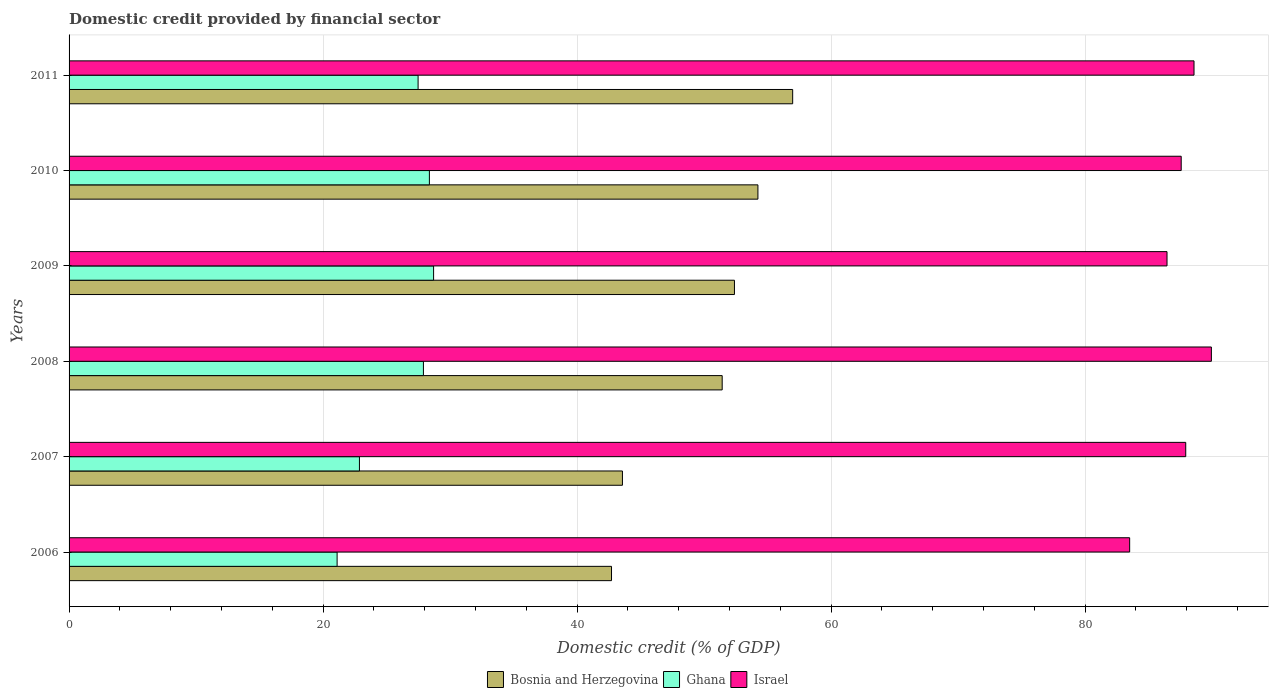How many different coloured bars are there?
Offer a very short reply. 3. How many groups of bars are there?
Keep it short and to the point. 6. Are the number of bars per tick equal to the number of legend labels?
Your answer should be very brief. Yes. Are the number of bars on each tick of the Y-axis equal?
Provide a succinct answer. Yes. How many bars are there on the 6th tick from the top?
Offer a very short reply. 3. How many bars are there on the 5th tick from the bottom?
Your answer should be very brief. 3. What is the label of the 2nd group of bars from the top?
Your answer should be very brief. 2010. What is the domestic credit in Ghana in 2007?
Keep it short and to the point. 22.86. Across all years, what is the maximum domestic credit in Israel?
Your answer should be very brief. 89.94. Across all years, what is the minimum domestic credit in Ghana?
Your answer should be compact. 21.1. In which year was the domestic credit in Bosnia and Herzegovina maximum?
Keep it short and to the point. 2011. In which year was the domestic credit in Israel minimum?
Your answer should be compact. 2006. What is the total domestic credit in Israel in the graph?
Your answer should be compact. 523.95. What is the difference between the domestic credit in Ghana in 2007 and that in 2009?
Ensure brevity in your answer.  -5.84. What is the difference between the domestic credit in Bosnia and Herzegovina in 2008 and the domestic credit in Ghana in 2007?
Your answer should be compact. 28.56. What is the average domestic credit in Israel per year?
Offer a very short reply. 87.32. In the year 2010, what is the difference between the domestic credit in Bosnia and Herzegovina and domestic credit in Ghana?
Provide a succinct answer. 25.87. What is the ratio of the domestic credit in Bosnia and Herzegovina in 2006 to that in 2007?
Your answer should be compact. 0.98. Is the domestic credit in Ghana in 2008 less than that in 2009?
Provide a short and direct response. Yes. What is the difference between the highest and the second highest domestic credit in Ghana?
Offer a very short reply. 0.33. What is the difference between the highest and the lowest domestic credit in Bosnia and Herzegovina?
Ensure brevity in your answer.  14.26. In how many years, is the domestic credit in Israel greater than the average domestic credit in Israel taken over all years?
Your answer should be very brief. 4. What does the 3rd bar from the top in 2010 represents?
Ensure brevity in your answer.  Bosnia and Herzegovina. What does the 1st bar from the bottom in 2010 represents?
Your answer should be very brief. Bosnia and Herzegovina. Are all the bars in the graph horizontal?
Make the answer very short. Yes. Where does the legend appear in the graph?
Your answer should be compact. Bottom center. How many legend labels are there?
Keep it short and to the point. 3. What is the title of the graph?
Offer a terse response. Domestic credit provided by financial sector. What is the label or title of the X-axis?
Provide a short and direct response. Domestic credit (% of GDP). What is the label or title of the Y-axis?
Give a very brief answer. Years. What is the Domestic credit (% of GDP) in Bosnia and Herzegovina in 2006?
Offer a terse response. 42.71. What is the Domestic credit (% of GDP) in Ghana in 2006?
Provide a succinct answer. 21.1. What is the Domestic credit (% of GDP) in Israel in 2006?
Your answer should be very brief. 83.51. What is the Domestic credit (% of GDP) in Bosnia and Herzegovina in 2007?
Provide a short and direct response. 43.57. What is the Domestic credit (% of GDP) of Ghana in 2007?
Provide a succinct answer. 22.86. What is the Domestic credit (% of GDP) of Israel in 2007?
Keep it short and to the point. 87.92. What is the Domestic credit (% of GDP) in Bosnia and Herzegovina in 2008?
Offer a very short reply. 51.42. What is the Domestic credit (% of GDP) in Ghana in 2008?
Make the answer very short. 27.9. What is the Domestic credit (% of GDP) of Israel in 2008?
Provide a succinct answer. 89.94. What is the Domestic credit (% of GDP) of Bosnia and Herzegovina in 2009?
Give a very brief answer. 52.39. What is the Domestic credit (% of GDP) in Ghana in 2009?
Offer a terse response. 28.7. What is the Domestic credit (% of GDP) in Israel in 2009?
Make the answer very short. 86.45. What is the Domestic credit (% of GDP) in Bosnia and Herzegovina in 2010?
Provide a short and direct response. 54.24. What is the Domestic credit (% of GDP) of Ghana in 2010?
Provide a short and direct response. 28.37. What is the Domestic credit (% of GDP) in Israel in 2010?
Offer a terse response. 87.56. What is the Domestic credit (% of GDP) in Bosnia and Herzegovina in 2011?
Offer a very short reply. 56.97. What is the Domestic credit (% of GDP) in Ghana in 2011?
Provide a succinct answer. 27.48. What is the Domestic credit (% of GDP) in Israel in 2011?
Offer a terse response. 88.57. Across all years, what is the maximum Domestic credit (% of GDP) in Bosnia and Herzegovina?
Provide a short and direct response. 56.97. Across all years, what is the maximum Domestic credit (% of GDP) in Ghana?
Offer a terse response. 28.7. Across all years, what is the maximum Domestic credit (% of GDP) in Israel?
Offer a terse response. 89.94. Across all years, what is the minimum Domestic credit (% of GDP) of Bosnia and Herzegovina?
Your response must be concise. 42.71. Across all years, what is the minimum Domestic credit (% of GDP) in Ghana?
Offer a very short reply. 21.1. Across all years, what is the minimum Domestic credit (% of GDP) in Israel?
Provide a short and direct response. 83.51. What is the total Domestic credit (% of GDP) in Bosnia and Herzegovina in the graph?
Offer a very short reply. 301.3. What is the total Domestic credit (% of GDP) of Ghana in the graph?
Offer a very short reply. 156.42. What is the total Domestic credit (% of GDP) in Israel in the graph?
Keep it short and to the point. 523.95. What is the difference between the Domestic credit (% of GDP) in Bosnia and Herzegovina in 2006 and that in 2007?
Provide a short and direct response. -0.86. What is the difference between the Domestic credit (% of GDP) of Ghana in 2006 and that in 2007?
Make the answer very short. -1.76. What is the difference between the Domestic credit (% of GDP) in Israel in 2006 and that in 2007?
Keep it short and to the point. -4.42. What is the difference between the Domestic credit (% of GDP) in Bosnia and Herzegovina in 2006 and that in 2008?
Give a very brief answer. -8.71. What is the difference between the Domestic credit (% of GDP) in Ghana in 2006 and that in 2008?
Offer a very short reply. -6.8. What is the difference between the Domestic credit (% of GDP) of Israel in 2006 and that in 2008?
Give a very brief answer. -6.43. What is the difference between the Domestic credit (% of GDP) of Bosnia and Herzegovina in 2006 and that in 2009?
Keep it short and to the point. -9.68. What is the difference between the Domestic credit (% of GDP) in Ghana in 2006 and that in 2009?
Your answer should be very brief. -7.6. What is the difference between the Domestic credit (% of GDP) of Israel in 2006 and that in 2009?
Give a very brief answer. -2.94. What is the difference between the Domestic credit (% of GDP) in Bosnia and Herzegovina in 2006 and that in 2010?
Make the answer very short. -11.53. What is the difference between the Domestic credit (% of GDP) of Ghana in 2006 and that in 2010?
Provide a short and direct response. -7.27. What is the difference between the Domestic credit (% of GDP) of Israel in 2006 and that in 2010?
Your response must be concise. -4.06. What is the difference between the Domestic credit (% of GDP) in Bosnia and Herzegovina in 2006 and that in 2011?
Provide a succinct answer. -14.26. What is the difference between the Domestic credit (% of GDP) of Ghana in 2006 and that in 2011?
Your answer should be very brief. -6.38. What is the difference between the Domestic credit (% of GDP) in Israel in 2006 and that in 2011?
Ensure brevity in your answer.  -5.07. What is the difference between the Domestic credit (% of GDP) in Bosnia and Herzegovina in 2007 and that in 2008?
Provide a short and direct response. -7.85. What is the difference between the Domestic credit (% of GDP) in Ghana in 2007 and that in 2008?
Offer a terse response. -5.04. What is the difference between the Domestic credit (% of GDP) in Israel in 2007 and that in 2008?
Provide a succinct answer. -2.02. What is the difference between the Domestic credit (% of GDP) in Bosnia and Herzegovina in 2007 and that in 2009?
Your answer should be very brief. -8.82. What is the difference between the Domestic credit (% of GDP) of Ghana in 2007 and that in 2009?
Your answer should be compact. -5.84. What is the difference between the Domestic credit (% of GDP) in Israel in 2007 and that in 2009?
Give a very brief answer. 1.47. What is the difference between the Domestic credit (% of GDP) of Bosnia and Herzegovina in 2007 and that in 2010?
Provide a succinct answer. -10.67. What is the difference between the Domestic credit (% of GDP) of Ghana in 2007 and that in 2010?
Provide a succinct answer. -5.51. What is the difference between the Domestic credit (% of GDP) in Israel in 2007 and that in 2010?
Keep it short and to the point. 0.36. What is the difference between the Domestic credit (% of GDP) in Bosnia and Herzegovina in 2007 and that in 2011?
Offer a terse response. -13.4. What is the difference between the Domestic credit (% of GDP) in Ghana in 2007 and that in 2011?
Keep it short and to the point. -4.62. What is the difference between the Domestic credit (% of GDP) in Israel in 2007 and that in 2011?
Provide a short and direct response. -0.65. What is the difference between the Domestic credit (% of GDP) of Bosnia and Herzegovina in 2008 and that in 2009?
Keep it short and to the point. -0.97. What is the difference between the Domestic credit (% of GDP) in Ghana in 2008 and that in 2009?
Provide a short and direct response. -0.8. What is the difference between the Domestic credit (% of GDP) of Israel in 2008 and that in 2009?
Ensure brevity in your answer.  3.49. What is the difference between the Domestic credit (% of GDP) in Bosnia and Herzegovina in 2008 and that in 2010?
Make the answer very short. -2.81. What is the difference between the Domestic credit (% of GDP) of Ghana in 2008 and that in 2010?
Offer a very short reply. -0.47. What is the difference between the Domestic credit (% of GDP) in Israel in 2008 and that in 2010?
Your answer should be very brief. 2.38. What is the difference between the Domestic credit (% of GDP) of Bosnia and Herzegovina in 2008 and that in 2011?
Provide a short and direct response. -5.55. What is the difference between the Domestic credit (% of GDP) of Ghana in 2008 and that in 2011?
Give a very brief answer. 0.42. What is the difference between the Domestic credit (% of GDP) in Israel in 2008 and that in 2011?
Give a very brief answer. 1.37. What is the difference between the Domestic credit (% of GDP) of Bosnia and Herzegovina in 2009 and that in 2010?
Give a very brief answer. -1.85. What is the difference between the Domestic credit (% of GDP) of Ghana in 2009 and that in 2010?
Ensure brevity in your answer.  0.33. What is the difference between the Domestic credit (% of GDP) of Israel in 2009 and that in 2010?
Your answer should be compact. -1.12. What is the difference between the Domestic credit (% of GDP) of Bosnia and Herzegovina in 2009 and that in 2011?
Keep it short and to the point. -4.58. What is the difference between the Domestic credit (% of GDP) of Ghana in 2009 and that in 2011?
Keep it short and to the point. 1.22. What is the difference between the Domestic credit (% of GDP) of Israel in 2009 and that in 2011?
Make the answer very short. -2.12. What is the difference between the Domestic credit (% of GDP) of Bosnia and Herzegovina in 2010 and that in 2011?
Keep it short and to the point. -2.74. What is the difference between the Domestic credit (% of GDP) in Ghana in 2010 and that in 2011?
Provide a short and direct response. 0.89. What is the difference between the Domestic credit (% of GDP) of Israel in 2010 and that in 2011?
Your response must be concise. -1.01. What is the difference between the Domestic credit (% of GDP) of Bosnia and Herzegovina in 2006 and the Domestic credit (% of GDP) of Ghana in 2007?
Your response must be concise. 19.85. What is the difference between the Domestic credit (% of GDP) of Bosnia and Herzegovina in 2006 and the Domestic credit (% of GDP) of Israel in 2007?
Provide a short and direct response. -45.21. What is the difference between the Domestic credit (% of GDP) in Ghana in 2006 and the Domestic credit (% of GDP) in Israel in 2007?
Your response must be concise. -66.82. What is the difference between the Domestic credit (% of GDP) in Bosnia and Herzegovina in 2006 and the Domestic credit (% of GDP) in Ghana in 2008?
Ensure brevity in your answer.  14.81. What is the difference between the Domestic credit (% of GDP) of Bosnia and Herzegovina in 2006 and the Domestic credit (% of GDP) of Israel in 2008?
Your answer should be compact. -47.23. What is the difference between the Domestic credit (% of GDP) of Ghana in 2006 and the Domestic credit (% of GDP) of Israel in 2008?
Make the answer very short. -68.84. What is the difference between the Domestic credit (% of GDP) in Bosnia and Herzegovina in 2006 and the Domestic credit (% of GDP) in Ghana in 2009?
Give a very brief answer. 14.01. What is the difference between the Domestic credit (% of GDP) of Bosnia and Herzegovina in 2006 and the Domestic credit (% of GDP) of Israel in 2009?
Your response must be concise. -43.74. What is the difference between the Domestic credit (% of GDP) in Ghana in 2006 and the Domestic credit (% of GDP) in Israel in 2009?
Provide a succinct answer. -65.34. What is the difference between the Domestic credit (% of GDP) of Bosnia and Herzegovina in 2006 and the Domestic credit (% of GDP) of Ghana in 2010?
Make the answer very short. 14.34. What is the difference between the Domestic credit (% of GDP) of Bosnia and Herzegovina in 2006 and the Domestic credit (% of GDP) of Israel in 2010?
Give a very brief answer. -44.85. What is the difference between the Domestic credit (% of GDP) in Ghana in 2006 and the Domestic credit (% of GDP) in Israel in 2010?
Your answer should be very brief. -66.46. What is the difference between the Domestic credit (% of GDP) in Bosnia and Herzegovina in 2006 and the Domestic credit (% of GDP) in Ghana in 2011?
Ensure brevity in your answer.  15.23. What is the difference between the Domestic credit (% of GDP) of Bosnia and Herzegovina in 2006 and the Domestic credit (% of GDP) of Israel in 2011?
Your response must be concise. -45.86. What is the difference between the Domestic credit (% of GDP) in Ghana in 2006 and the Domestic credit (% of GDP) in Israel in 2011?
Keep it short and to the point. -67.47. What is the difference between the Domestic credit (% of GDP) of Bosnia and Herzegovina in 2007 and the Domestic credit (% of GDP) of Ghana in 2008?
Your answer should be compact. 15.67. What is the difference between the Domestic credit (% of GDP) in Bosnia and Herzegovina in 2007 and the Domestic credit (% of GDP) in Israel in 2008?
Provide a short and direct response. -46.37. What is the difference between the Domestic credit (% of GDP) of Ghana in 2007 and the Domestic credit (% of GDP) of Israel in 2008?
Ensure brevity in your answer.  -67.08. What is the difference between the Domestic credit (% of GDP) in Bosnia and Herzegovina in 2007 and the Domestic credit (% of GDP) in Ghana in 2009?
Ensure brevity in your answer.  14.87. What is the difference between the Domestic credit (% of GDP) in Bosnia and Herzegovina in 2007 and the Domestic credit (% of GDP) in Israel in 2009?
Provide a succinct answer. -42.88. What is the difference between the Domestic credit (% of GDP) in Ghana in 2007 and the Domestic credit (% of GDP) in Israel in 2009?
Provide a succinct answer. -63.58. What is the difference between the Domestic credit (% of GDP) of Bosnia and Herzegovina in 2007 and the Domestic credit (% of GDP) of Ghana in 2010?
Offer a terse response. 15.2. What is the difference between the Domestic credit (% of GDP) of Bosnia and Herzegovina in 2007 and the Domestic credit (% of GDP) of Israel in 2010?
Your answer should be compact. -43.99. What is the difference between the Domestic credit (% of GDP) of Ghana in 2007 and the Domestic credit (% of GDP) of Israel in 2010?
Your answer should be compact. -64.7. What is the difference between the Domestic credit (% of GDP) of Bosnia and Herzegovina in 2007 and the Domestic credit (% of GDP) of Ghana in 2011?
Keep it short and to the point. 16.09. What is the difference between the Domestic credit (% of GDP) of Bosnia and Herzegovina in 2007 and the Domestic credit (% of GDP) of Israel in 2011?
Offer a terse response. -45. What is the difference between the Domestic credit (% of GDP) of Ghana in 2007 and the Domestic credit (% of GDP) of Israel in 2011?
Give a very brief answer. -65.71. What is the difference between the Domestic credit (% of GDP) in Bosnia and Herzegovina in 2008 and the Domestic credit (% of GDP) in Ghana in 2009?
Offer a very short reply. 22.72. What is the difference between the Domestic credit (% of GDP) in Bosnia and Herzegovina in 2008 and the Domestic credit (% of GDP) in Israel in 2009?
Ensure brevity in your answer.  -35.02. What is the difference between the Domestic credit (% of GDP) of Ghana in 2008 and the Domestic credit (% of GDP) of Israel in 2009?
Your answer should be compact. -58.55. What is the difference between the Domestic credit (% of GDP) of Bosnia and Herzegovina in 2008 and the Domestic credit (% of GDP) of Ghana in 2010?
Your answer should be compact. 23.05. What is the difference between the Domestic credit (% of GDP) of Bosnia and Herzegovina in 2008 and the Domestic credit (% of GDP) of Israel in 2010?
Provide a succinct answer. -36.14. What is the difference between the Domestic credit (% of GDP) of Ghana in 2008 and the Domestic credit (% of GDP) of Israel in 2010?
Your response must be concise. -59.66. What is the difference between the Domestic credit (% of GDP) of Bosnia and Herzegovina in 2008 and the Domestic credit (% of GDP) of Ghana in 2011?
Offer a very short reply. 23.94. What is the difference between the Domestic credit (% of GDP) in Bosnia and Herzegovina in 2008 and the Domestic credit (% of GDP) in Israel in 2011?
Keep it short and to the point. -37.15. What is the difference between the Domestic credit (% of GDP) of Ghana in 2008 and the Domestic credit (% of GDP) of Israel in 2011?
Offer a terse response. -60.67. What is the difference between the Domestic credit (% of GDP) of Bosnia and Herzegovina in 2009 and the Domestic credit (% of GDP) of Ghana in 2010?
Your answer should be very brief. 24.02. What is the difference between the Domestic credit (% of GDP) in Bosnia and Herzegovina in 2009 and the Domestic credit (% of GDP) in Israel in 2010?
Your answer should be compact. -35.17. What is the difference between the Domestic credit (% of GDP) in Ghana in 2009 and the Domestic credit (% of GDP) in Israel in 2010?
Offer a very short reply. -58.86. What is the difference between the Domestic credit (% of GDP) in Bosnia and Herzegovina in 2009 and the Domestic credit (% of GDP) in Ghana in 2011?
Your answer should be very brief. 24.91. What is the difference between the Domestic credit (% of GDP) in Bosnia and Herzegovina in 2009 and the Domestic credit (% of GDP) in Israel in 2011?
Give a very brief answer. -36.18. What is the difference between the Domestic credit (% of GDP) of Ghana in 2009 and the Domestic credit (% of GDP) of Israel in 2011?
Offer a very short reply. -59.87. What is the difference between the Domestic credit (% of GDP) of Bosnia and Herzegovina in 2010 and the Domestic credit (% of GDP) of Ghana in 2011?
Ensure brevity in your answer.  26.76. What is the difference between the Domestic credit (% of GDP) of Bosnia and Herzegovina in 2010 and the Domestic credit (% of GDP) of Israel in 2011?
Make the answer very short. -34.33. What is the difference between the Domestic credit (% of GDP) in Ghana in 2010 and the Domestic credit (% of GDP) in Israel in 2011?
Provide a succinct answer. -60.2. What is the average Domestic credit (% of GDP) of Bosnia and Herzegovina per year?
Provide a short and direct response. 50.22. What is the average Domestic credit (% of GDP) in Ghana per year?
Offer a very short reply. 26.07. What is the average Domestic credit (% of GDP) in Israel per year?
Provide a short and direct response. 87.32. In the year 2006, what is the difference between the Domestic credit (% of GDP) in Bosnia and Herzegovina and Domestic credit (% of GDP) in Ghana?
Keep it short and to the point. 21.6. In the year 2006, what is the difference between the Domestic credit (% of GDP) in Bosnia and Herzegovina and Domestic credit (% of GDP) in Israel?
Keep it short and to the point. -40.8. In the year 2006, what is the difference between the Domestic credit (% of GDP) of Ghana and Domestic credit (% of GDP) of Israel?
Offer a terse response. -62.4. In the year 2007, what is the difference between the Domestic credit (% of GDP) of Bosnia and Herzegovina and Domestic credit (% of GDP) of Ghana?
Your response must be concise. 20.71. In the year 2007, what is the difference between the Domestic credit (% of GDP) in Bosnia and Herzegovina and Domestic credit (% of GDP) in Israel?
Give a very brief answer. -44.35. In the year 2007, what is the difference between the Domestic credit (% of GDP) of Ghana and Domestic credit (% of GDP) of Israel?
Provide a short and direct response. -65.06. In the year 2008, what is the difference between the Domestic credit (% of GDP) of Bosnia and Herzegovina and Domestic credit (% of GDP) of Ghana?
Offer a terse response. 23.52. In the year 2008, what is the difference between the Domestic credit (% of GDP) of Bosnia and Herzegovina and Domestic credit (% of GDP) of Israel?
Your response must be concise. -38.52. In the year 2008, what is the difference between the Domestic credit (% of GDP) in Ghana and Domestic credit (% of GDP) in Israel?
Keep it short and to the point. -62.04. In the year 2009, what is the difference between the Domestic credit (% of GDP) in Bosnia and Herzegovina and Domestic credit (% of GDP) in Ghana?
Offer a very short reply. 23.69. In the year 2009, what is the difference between the Domestic credit (% of GDP) of Bosnia and Herzegovina and Domestic credit (% of GDP) of Israel?
Your response must be concise. -34.06. In the year 2009, what is the difference between the Domestic credit (% of GDP) of Ghana and Domestic credit (% of GDP) of Israel?
Offer a terse response. -57.75. In the year 2010, what is the difference between the Domestic credit (% of GDP) in Bosnia and Herzegovina and Domestic credit (% of GDP) in Ghana?
Make the answer very short. 25.87. In the year 2010, what is the difference between the Domestic credit (% of GDP) of Bosnia and Herzegovina and Domestic credit (% of GDP) of Israel?
Keep it short and to the point. -33.33. In the year 2010, what is the difference between the Domestic credit (% of GDP) in Ghana and Domestic credit (% of GDP) in Israel?
Ensure brevity in your answer.  -59.19. In the year 2011, what is the difference between the Domestic credit (% of GDP) of Bosnia and Herzegovina and Domestic credit (% of GDP) of Ghana?
Your answer should be compact. 29.49. In the year 2011, what is the difference between the Domestic credit (% of GDP) of Bosnia and Herzegovina and Domestic credit (% of GDP) of Israel?
Give a very brief answer. -31.6. In the year 2011, what is the difference between the Domestic credit (% of GDP) in Ghana and Domestic credit (% of GDP) in Israel?
Provide a succinct answer. -61.09. What is the ratio of the Domestic credit (% of GDP) of Bosnia and Herzegovina in 2006 to that in 2007?
Offer a very short reply. 0.98. What is the ratio of the Domestic credit (% of GDP) in Ghana in 2006 to that in 2007?
Your answer should be compact. 0.92. What is the ratio of the Domestic credit (% of GDP) of Israel in 2006 to that in 2007?
Keep it short and to the point. 0.95. What is the ratio of the Domestic credit (% of GDP) in Bosnia and Herzegovina in 2006 to that in 2008?
Give a very brief answer. 0.83. What is the ratio of the Domestic credit (% of GDP) of Ghana in 2006 to that in 2008?
Your answer should be very brief. 0.76. What is the ratio of the Domestic credit (% of GDP) in Israel in 2006 to that in 2008?
Your answer should be very brief. 0.93. What is the ratio of the Domestic credit (% of GDP) in Bosnia and Herzegovina in 2006 to that in 2009?
Offer a terse response. 0.82. What is the ratio of the Domestic credit (% of GDP) in Ghana in 2006 to that in 2009?
Your answer should be compact. 0.74. What is the ratio of the Domestic credit (% of GDP) of Israel in 2006 to that in 2009?
Give a very brief answer. 0.97. What is the ratio of the Domestic credit (% of GDP) of Bosnia and Herzegovina in 2006 to that in 2010?
Offer a terse response. 0.79. What is the ratio of the Domestic credit (% of GDP) of Ghana in 2006 to that in 2010?
Ensure brevity in your answer.  0.74. What is the ratio of the Domestic credit (% of GDP) in Israel in 2006 to that in 2010?
Offer a very short reply. 0.95. What is the ratio of the Domestic credit (% of GDP) in Bosnia and Herzegovina in 2006 to that in 2011?
Provide a succinct answer. 0.75. What is the ratio of the Domestic credit (% of GDP) in Ghana in 2006 to that in 2011?
Your answer should be very brief. 0.77. What is the ratio of the Domestic credit (% of GDP) in Israel in 2006 to that in 2011?
Give a very brief answer. 0.94. What is the ratio of the Domestic credit (% of GDP) of Bosnia and Herzegovina in 2007 to that in 2008?
Your response must be concise. 0.85. What is the ratio of the Domestic credit (% of GDP) in Ghana in 2007 to that in 2008?
Offer a very short reply. 0.82. What is the ratio of the Domestic credit (% of GDP) in Israel in 2007 to that in 2008?
Keep it short and to the point. 0.98. What is the ratio of the Domestic credit (% of GDP) in Bosnia and Herzegovina in 2007 to that in 2009?
Your response must be concise. 0.83. What is the ratio of the Domestic credit (% of GDP) of Ghana in 2007 to that in 2009?
Offer a very short reply. 0.8. What is the ratio of the Domestic credit (% of GDP) of Bosnia and Herzegovina in 2007 to that in 2010?
Your answer should be very brief. 0.8. What is the ratio of the Domestic credit (% of GDP) of Ghana in 2007 to that in 2010?
Your answer should be compact. 0.81. What is the ratio of the Domestic credit (% of GDP) of Israel in 2007 to that in 2010?
Provide a short and direct response. 1. What is the ratio of the Domestic credit (% of GDP) of Bosnia and Herzegovina in 2007 to that in 2011?
Provide a short and direct response. 0.76. What is the ratio of the Domestic credit (% of GDP) in Ghana in 2007 to that in 2011?
Keep it short and to the point. 0.83. What is the ratio of the Domestic credit (% of GDP) of Israel in 2007 to that in 2011?
Your answer should be compact. 0.99. What is the ratio of the Domestic credit (% of GDP) of Bosnia and Herzegovina in 2008 to that in 2009?
Offer a terse response. 0.98. What is the ratio of the Domestic credit (% of GDP) of Ghana in 2008 to that in 2009?
Ensure brevity in your answer.  0.97. What is the ratio of the Domestic credit (% of GDP) in Israel in 2008 to that in 2009?
Make the answer very short. 1.04. What is the ratio of the Domestic credit (% of GDP) of Bosnia and Herzegovina in 2008 to that in 2010?
Your answer should be very brief. 0.95. What is the ratio of the Domestic credit (% of GDP) of Ghana in 2008 to that in 2010?
Your response must be concise. 0.98. What is the ratio of the Domestic credit (% of GDP) of Israel in 2008 to that in 2010?
Give a very brief answer. 1.03. What is the ratio of the Domestic credit (% of GDP) in Bosnia and Herzegovina in 2008 to that in 2011?
Offer a very short reply. 0.9. What is the ratio of the Domestic credit (% of GDP) of Ghana in 2008 to that in 2011?
Keep it short and to the point. 1.02. What is the ratio of the Domestic credit (% of GDP) in Israel in 2008 to that in 2011?
Keep it short and to the point. 1.02. What is the ratio of the Domestic credit (% of GDP) in Bosnia and Herzegovina in 2009 to that in 2010?
Offer a very short reply. 0.97. What is the ratio of the Domestic credit (% of GDP) in Ghana in 2009 to that in 2010?
Your answer should be very brief. 1.01. What is the ratio of the Domestic credit (% of GDP) in Israel in 2009 to that in 2010?
Offer a very short reply. 0.99. What is the ratio of the Domestic credit (% of GDP) in Bosnia and Herzegovina in 2009 to that in 2011?
Offer a terse response. 0.92. What is the ratio of the Domestic credit (% of GDP) of Ghana in 2009 to that in 2011?
Your answer should be compact. 1.04. What is the ratio of the Domestic credit (% of GDP) in Israel in 2009 to that in 2011?
Your response must be concise. 0.98. What is the ratio of the Domestic credit (% of GDP) of Bosnia and Herzegovina in 2010 to that in 2011?
Ensure brevity in your answer.  0.95. What is the ratio of the Domestic credit (% of GDP) in Ghana in 2010 to that in 2011?
Provide a succinct answer. 1.03. What is the difference between the highest and the second highest Domestic credit (% of GDP) of Bosnia and Herzegovina?
Your answer should be very brief. 2.74. What is the difference between the highest and the second highest Domestic credit (% of GDP) in Ghana?
Keep it short and to the point. 0.33. What is the difference between the highest and the second highest Domestic credit (% of GDP) of Israel?
Provide a short and direct response. 1.37. What is the difference between the highest and the lowest Domestic credit (% of GDP) of Bosnia and Herzegovina?
Ensure brevity in your answer.  14.26. What is the difference between the highest and the lowest Domestic credit (% of GDP) of Ghana?
Ensure brevity in your answer.  7.6. What is the difference between the highest and the lowest Domestic credit (% of GDP) of Israel?
Offer a very short reply. 6.43. 